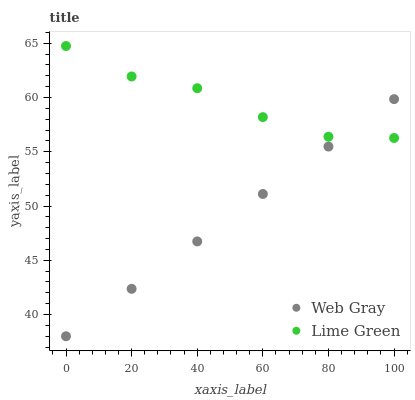Does Web Gray have the minimum area under the curve?
Answer yes or no. Yes. Does Lime Green have the maximum area under the curve?
Answer yes or no. Yes. Does Lime Green have the minimum area under the curve?
Answer yes or no. No. Is Web Gray the smoothest?
Answer yes or no. Yes. Is Lime Green the roughest?
Answer yes or no. Yes. Is Lime Green the smoothest?
Answer yes or no. No. Does Web Gray have the lowest value?
Answer yes or no. Yes. Does Lime Green have the lowest value?
Answer yes or no. No. Does Lime Green have the highest value?
Answer yes or no. Yes. Does Web Gray intersect Lime Green?
Answer yes or no. Yes. Is Web Gray less than Lime Green?
Answer yes or no. No. Is Web Gray greater than Lime Green?
Answer yes or no. No. 